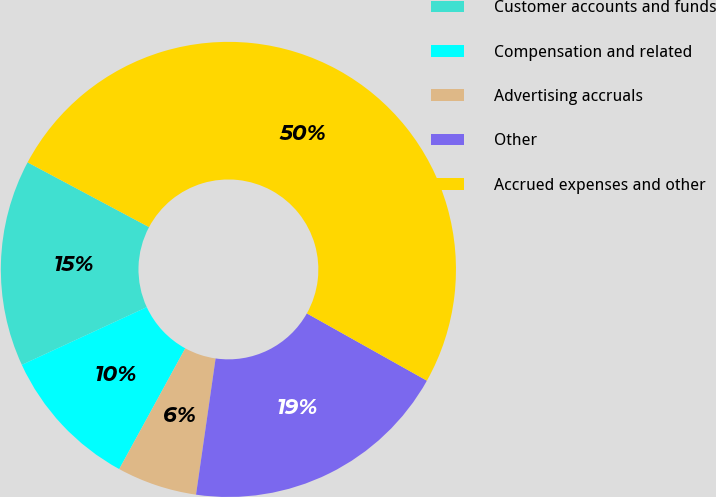Convert chart. <chart><loc_0><loc_0><loc_500><loc_500><pie_chart><fcel>Customer accounts and funds<fcel>Compensation and related<fcel>Advertising accruals<fcel>Other<fcel>Accrued expenses and other<nl><fcel>14.68%<fcel>10.15%<fcel>5.69%<fcel>19.14%<fcel>50.33%<nl></chart> 